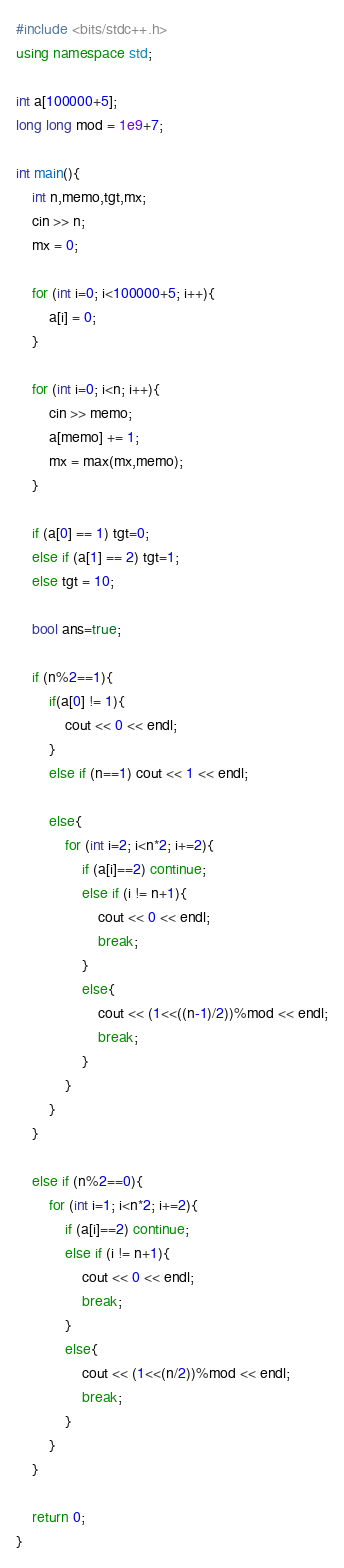Convert code to text. <code><loc_0><loc_0><loc_500><loc_500><_C++_>#include <bits/stdc++.h>
using namespace std;

int a[100000+5];
long long mod = 1e9+7;

int main(){
    int n,memo,tgt,mx;
    cin >> n;
    mx = 0;

    for (int i=0; i<100000+5; i++){
        a[i] = 0;
    }

    for (int i=0; i<n; i++){
        cin >> memo;
        a[memo] += 1;
        mx = max(mx,memo); 
    }

    if (a[0] == 1) tgt=0;
    else if (a[1] == 2) tgt=1;
    else tgt = 10;

    bool ans=true;

    if (n%2==1){
        if(a[0] != 1){
            cout << 0 << endl;
        }
        else if (n==1) cout << 1 << endl;
    
        else{
            for (int i=2; i<n*2; i+=2){
                if (a[i]==2) continue;
                else if (i != n+1){
                    cout << 0 << endl;
                    break;
                }
                else{
                    cout << (1<<((n-1)/2))%mod << endl;
                    break;
                }
            }
        }
    }

    else if (n%2==0){
        for (int i=1; i<n*2; i+=2){
            if (a[i]==2) continue;
            else if (i != n+1){
                cout << 0 << endl;
                break;
            }
            else{
                cout << (1<<(n/2))%mod << endl;
                break;
            }
        }
    }

    return 0;
}</code> 